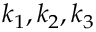Convert formula to latex. <formula><loc_0><loc_0><loc_500><loc_500>k _ { 1 } , k _ { 2 } , k _ { 3 }</formula> 